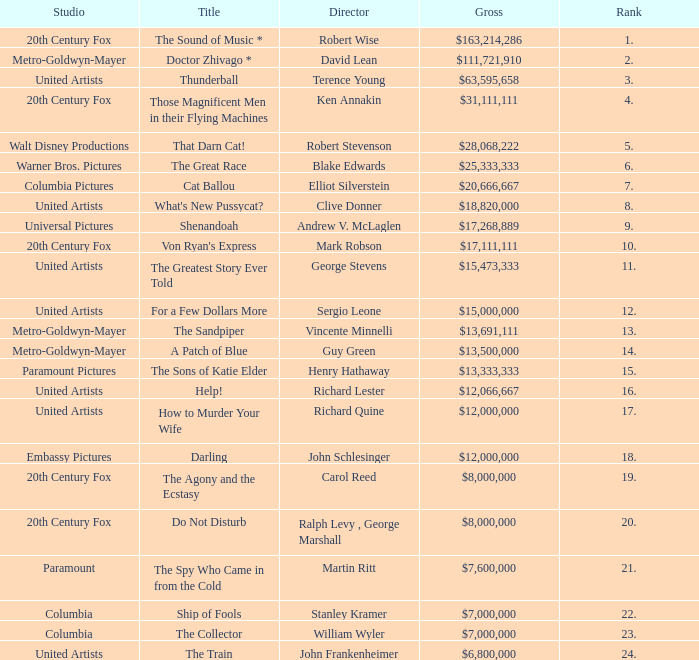What is the highest Rank, when Director is "Henry Hathaway"? 15.0. 